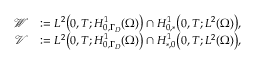<formula> <loc_0><loc_0><loc_500><loc_500>\begin{array} { r l } { \mathcal { W } } & { \colon = L ^ { 2 } \left ( 0 , T ; H _ { 0 , \Gamma _ { D } } ^ { 1 } ( \Omega ) \right ) \cap H _ { 0 , * } ^ { 1 } \left ( 0 , T ; L ^ { 2 } ( \Omega ) \right ) , } \\ { \mathcal { V } } & { \colon = L ^ { 2 } \left ( 0 , T ; H _ { 0 , \Gamma _ { D } } ^ { 1 } ( \Omega ) \right ) \cap H _ { * , 0 } ^ { 1 } \left ( 0 , T ; L ^ { 2 } ( \Omega ) \right ) , } \end{array}</formula> 